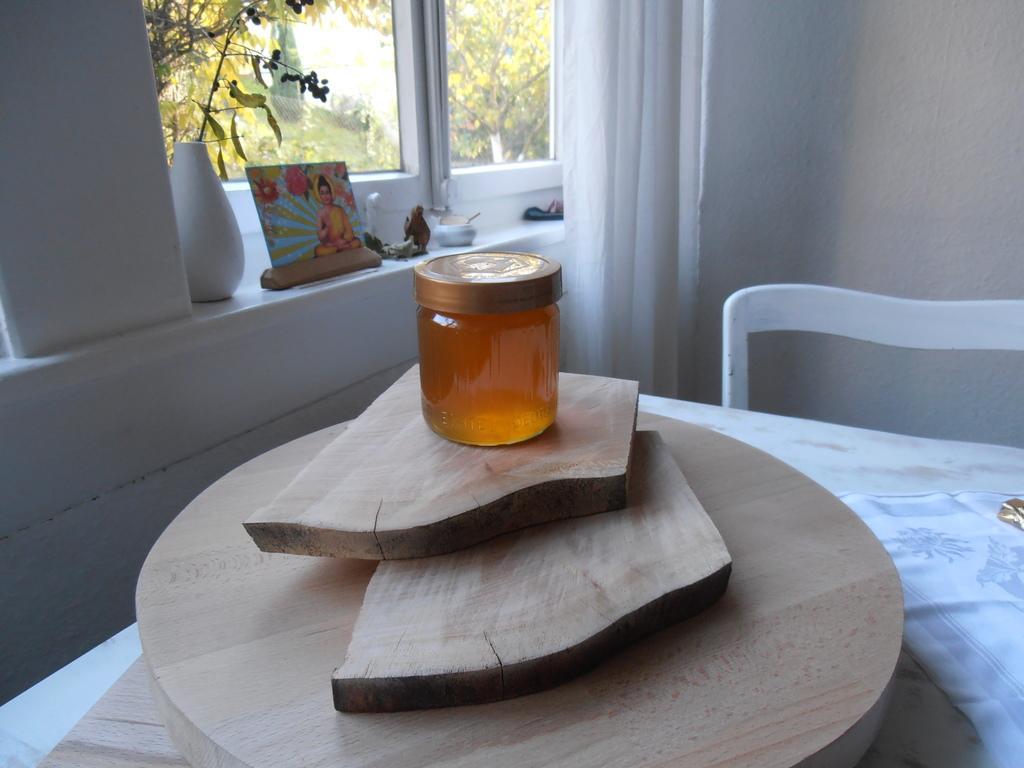Please provide a concise description of this image. In this picture we can see a table and a chair in the front, there is some wood present on the table, we can see a bottle on the wood, in the background there is a glass window and a curtain, from the glass we can see trees, there is a photo, a flower vase and some things present in the middle, on the right side there is a wall. 